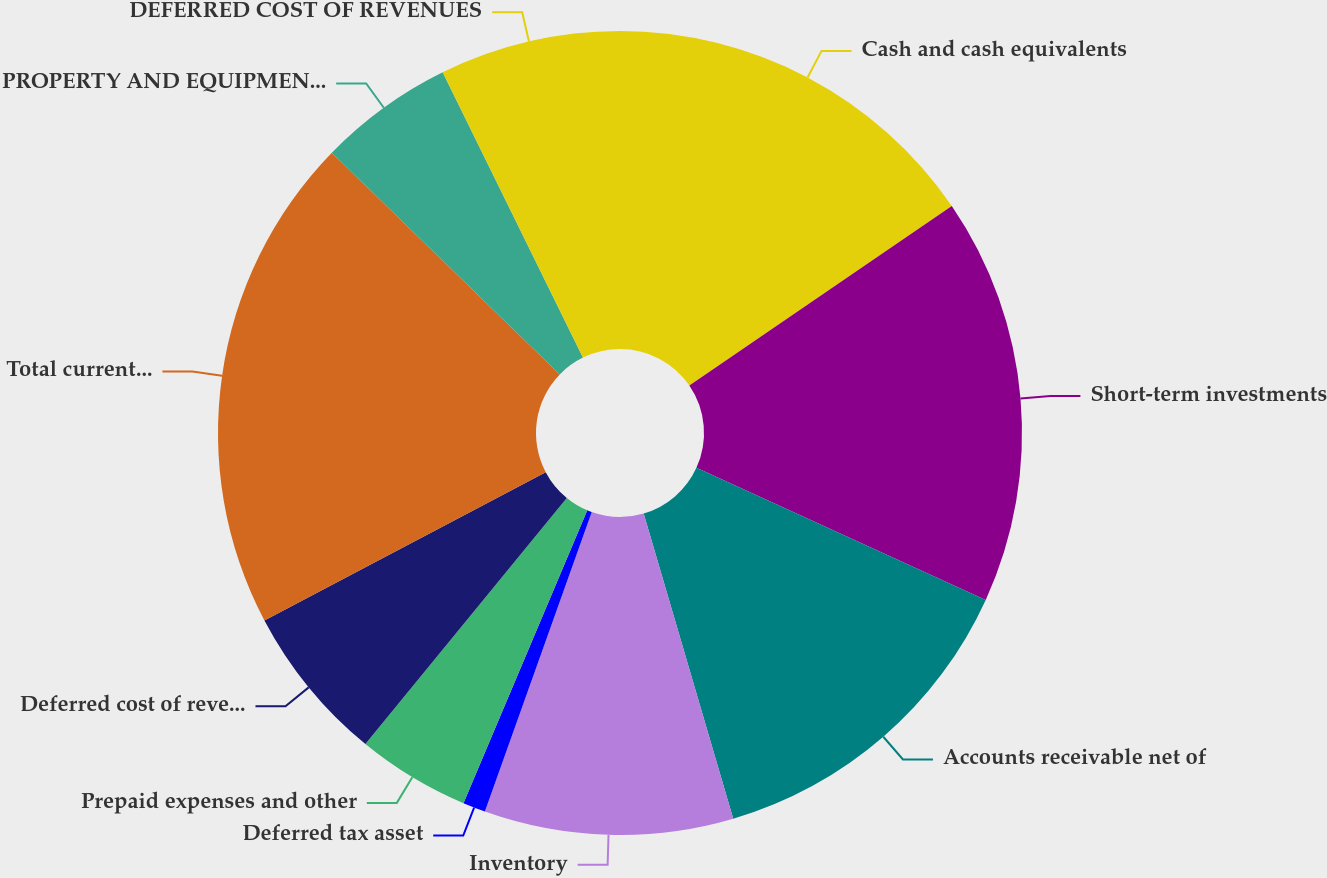Convert chart. <chart><loc_0><loc_0><loc_500><loc_500><pie_chart><fcel>Cash and cash equivalents<fcel>Short-term investments<fcel>Accounts receivable net of<fcel>Inventory<fcel>Deferred tax asset<fcel>Prepaid expenses and other<fcel>Deferred cost of revenues<fcel>Total current assets<fcel>PROPERTY AND EQUIPMENT-Net<fcel>DEFERRED COST OF REVENUES<nl><fcel>15.45%<fcel>16.36%<fcel>13.64%<fcel>10.0%<fcel>0.91%<fcel>4.55%<fcel>6.36%<fcel>20.0%<fcel>5.45%<fcel>7.27%<nl></chart> 